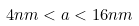<formula> <loc_0><loc_0><loc_500><loc_500>4 n m < a < 1 6 n m</formula> 